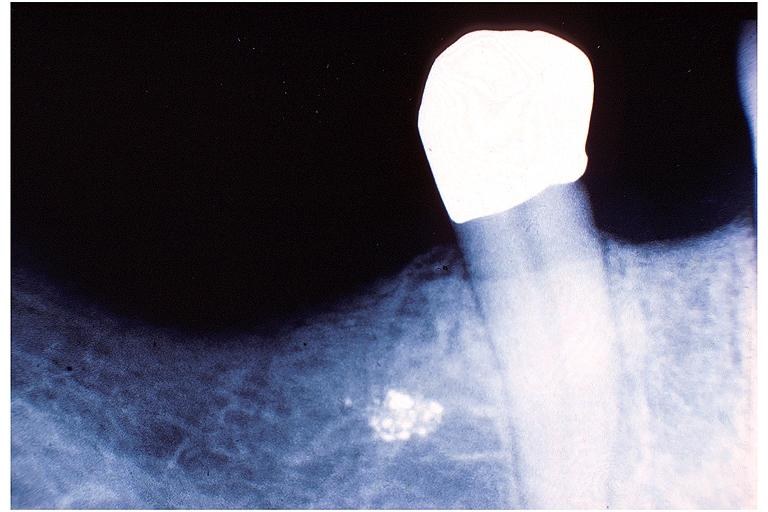s side showing patency right side present?
Answer the question using a single word or phrase. No 